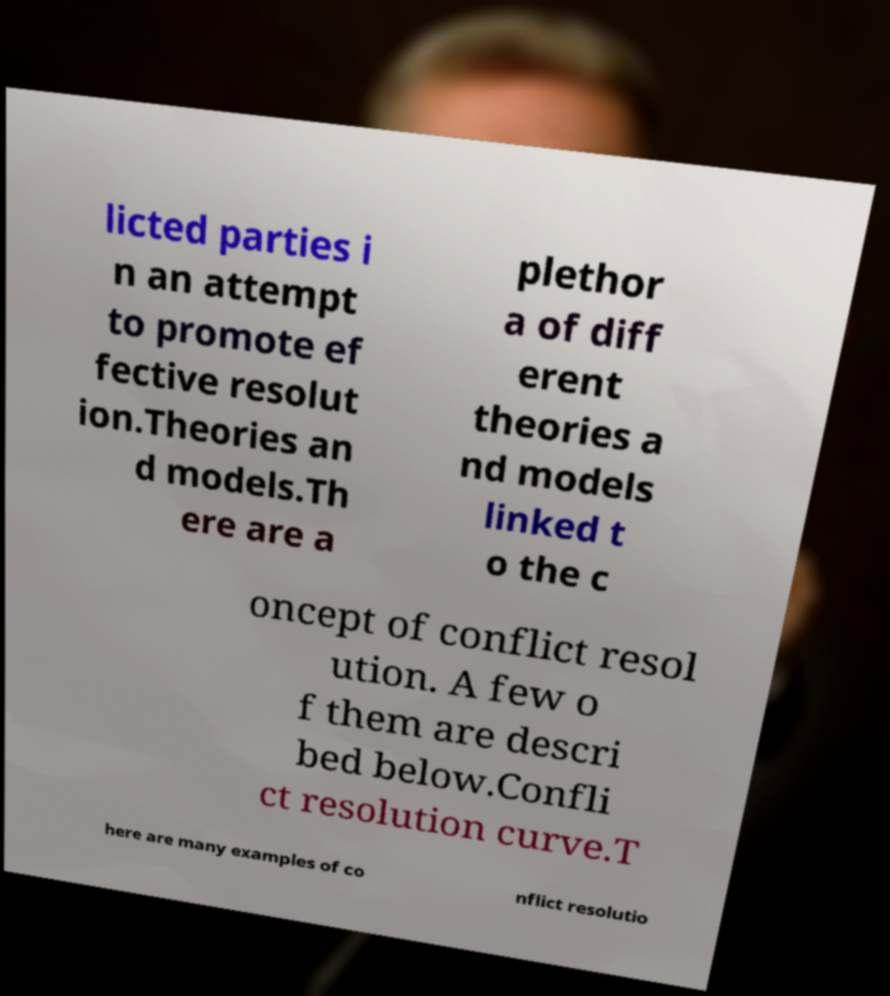For documentation purposes, I need the text within this image transcribed. Could you provide that? licted parties i n an attempt to promote ef fective resolut ion.Theories an d models.Th ere are a plethor a of diff erent theories a nd models linked t o the c oncept of conflict resol ution. A few o f them are descri bed below.Confli ct resolution curve.T here are many examples of co nflict resolutio 